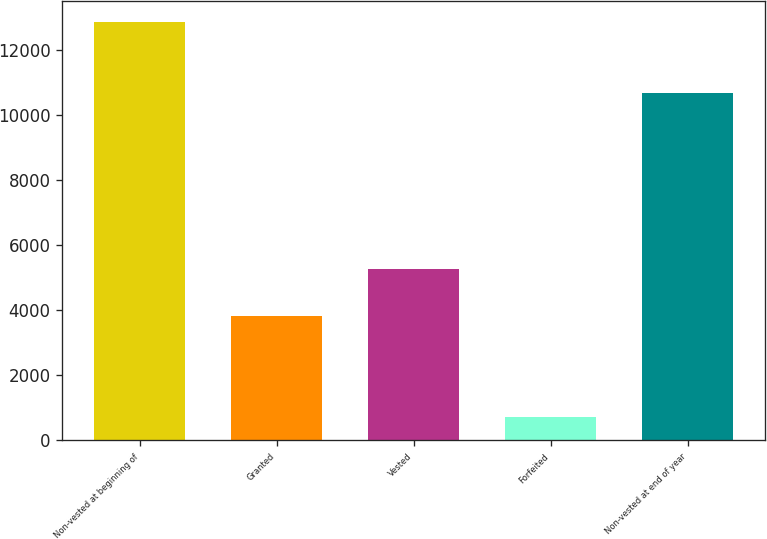Convert chart to OTSL. <chart><loc_0><loc_0><loc_500><loc_500><bar_chart><fcel>Non-vested at beginning of<fcel>Granted<fcel>Vested<fcel>Forfeited<fcel>Non-vested at end of year<nl><fcel>12850<fcel>3817<fcel>5278<fcel>715<fcel>10674<nl></chart> 